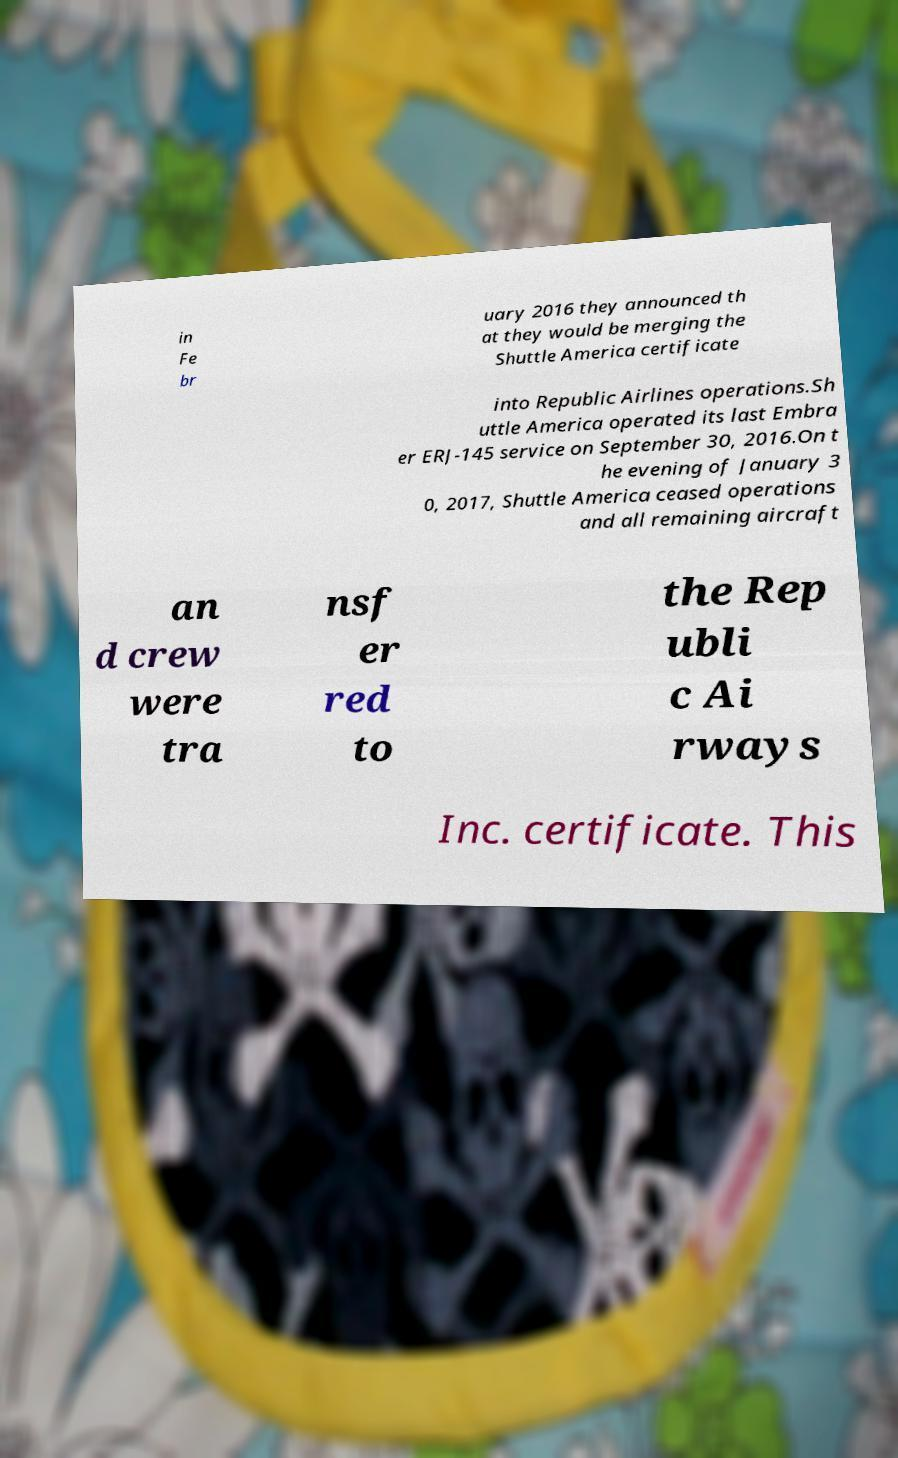What messages or text are displayed in this image? I need them in a readable, typed format. in Fe br uary 2016 they announced th at they would be merging the Shuttle America certificate into Republic Airlines operations.Sh uttle America operated its last Embra er ERJ-145 service on September 30, 2016.On t he evening of January 3 0, 2017, Shuttle America ceased operations and all remaining aircraft an d crew were tra nsf er red to the Rep ubli c Ai rways Inc. certificate. This 